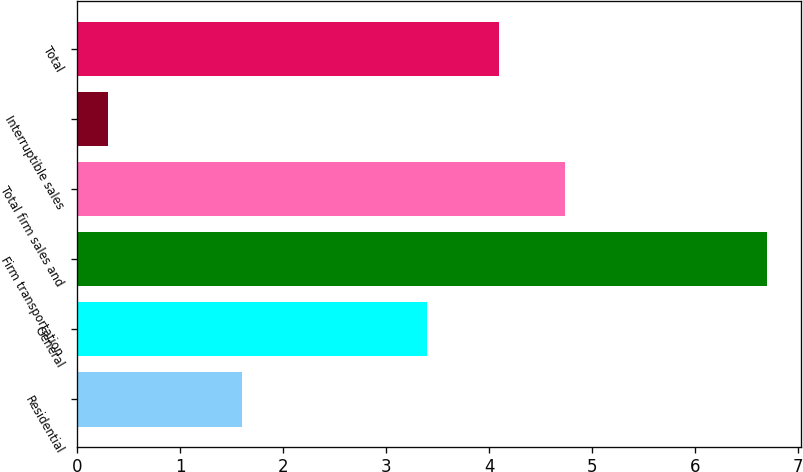Convert chart to OTSL. <chart><loc_0><loc_0><loc_500><loc_500><bar_chart><fcel>Residential<fcel>General<fcel>Firm transportation<fcel>Total firm sales and<fcel>Interruptible sales<fcel>Total<nl><fcel>1.6<fcel>3.4<fcel>6.7<fcel>4.74<fcel>0.3<fcel>4.1<nl></chart> 